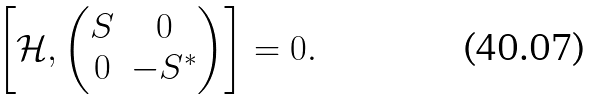<formula> <loc_0><loc_0><loc_500><loc_500>\left [ \mathcal { H } , \begin{pmatrix} S & 0 \\ 0 & - S ^ { * } \end{pmatrix} \right ] = 0 .</formula> 